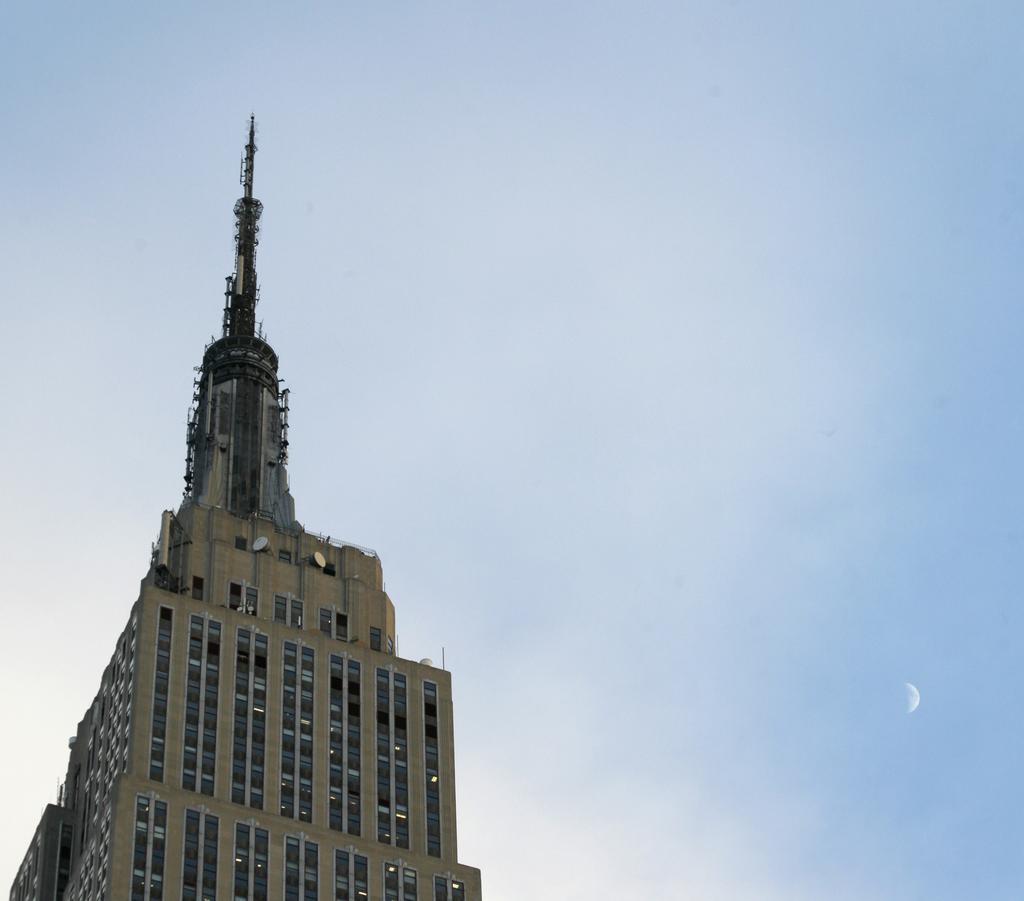Can you describe this image briefly? In this image we can see a building. In the background there is sky. On the right we can see the moon. 